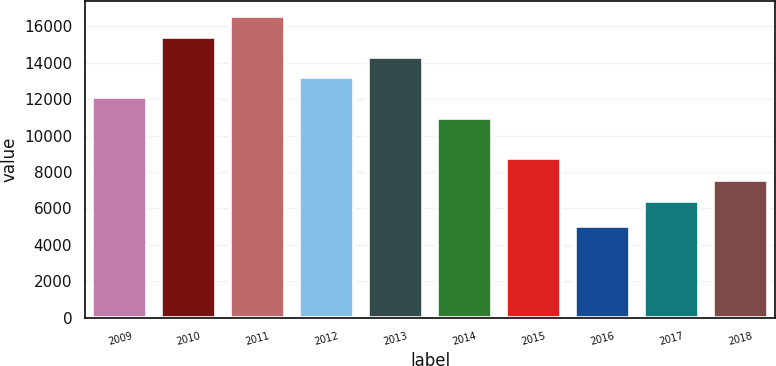Convert chart to OTSL. <chart><loc_0><loc_0><loc_500><loc_500><bar_chart><fcel>2009<fcel>2010<fcel>2011<fcel>2012<fcel>2013<fcel>2014<fcel>2015<fcel>2016<fcel>2017<fcel>2018<nl><fcel>12094.3<fcel>15442.6<fcel>16558.7<fcel>13210.4<fcel>14326.5<fcel>10978.2<fcel>8746<fcel>5058<fcel>6424<fcel>7540.1<nl></chart> 